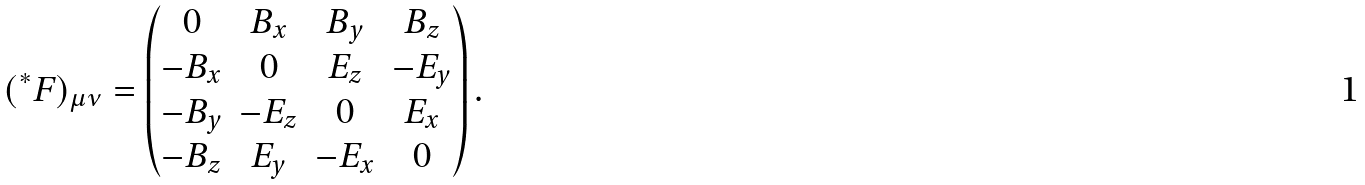<formula> <loc_0><loc_0><loc_500><loc_500>( ^ { * } F ) _ { \mu \nu } = \begin{pmatrix} 0 & B _ { x } & B _ { y } & B _ { z } \\ - B _ { x } & 0 & E _ { z } & - E _ { y } \\ - B _ { y } & - E _ { z } & 0 & E _ { x } \\ - B _ { z } & E _ { y } & - E _ { x } & 0 \end{pmatrix} .</formula> 